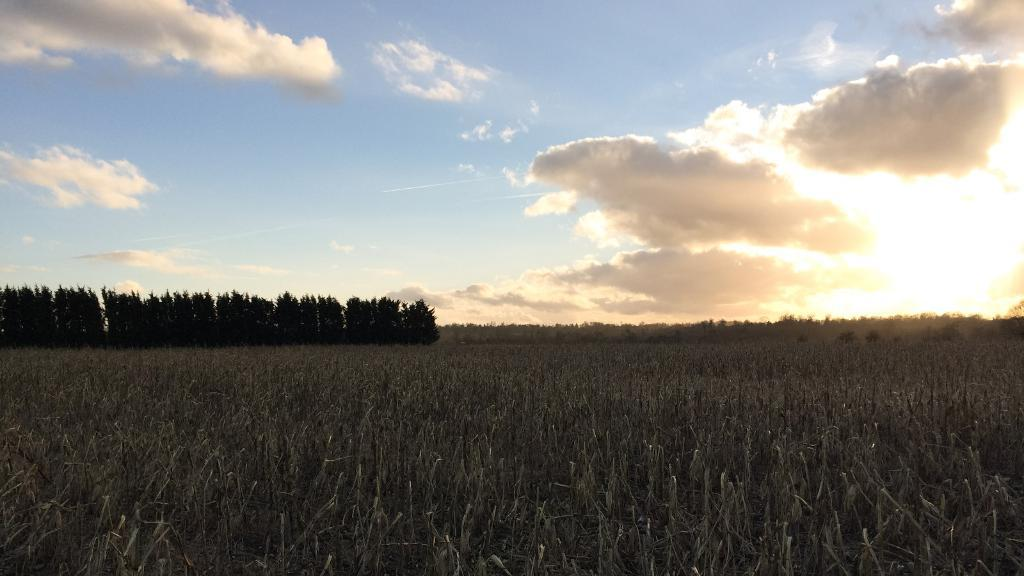What type of vegetation can be seen in the image? There is grass in the image. What other natural elements are present in the image? There are trees in the image. What is visible in the background of the image? The sky is visible in the image. What can be observed in the sky? Clouds and the sun are present in the sky. What type of detail can be seen on the wax in the image? There is no wax present in the image, so it is not possible to answer that question. 